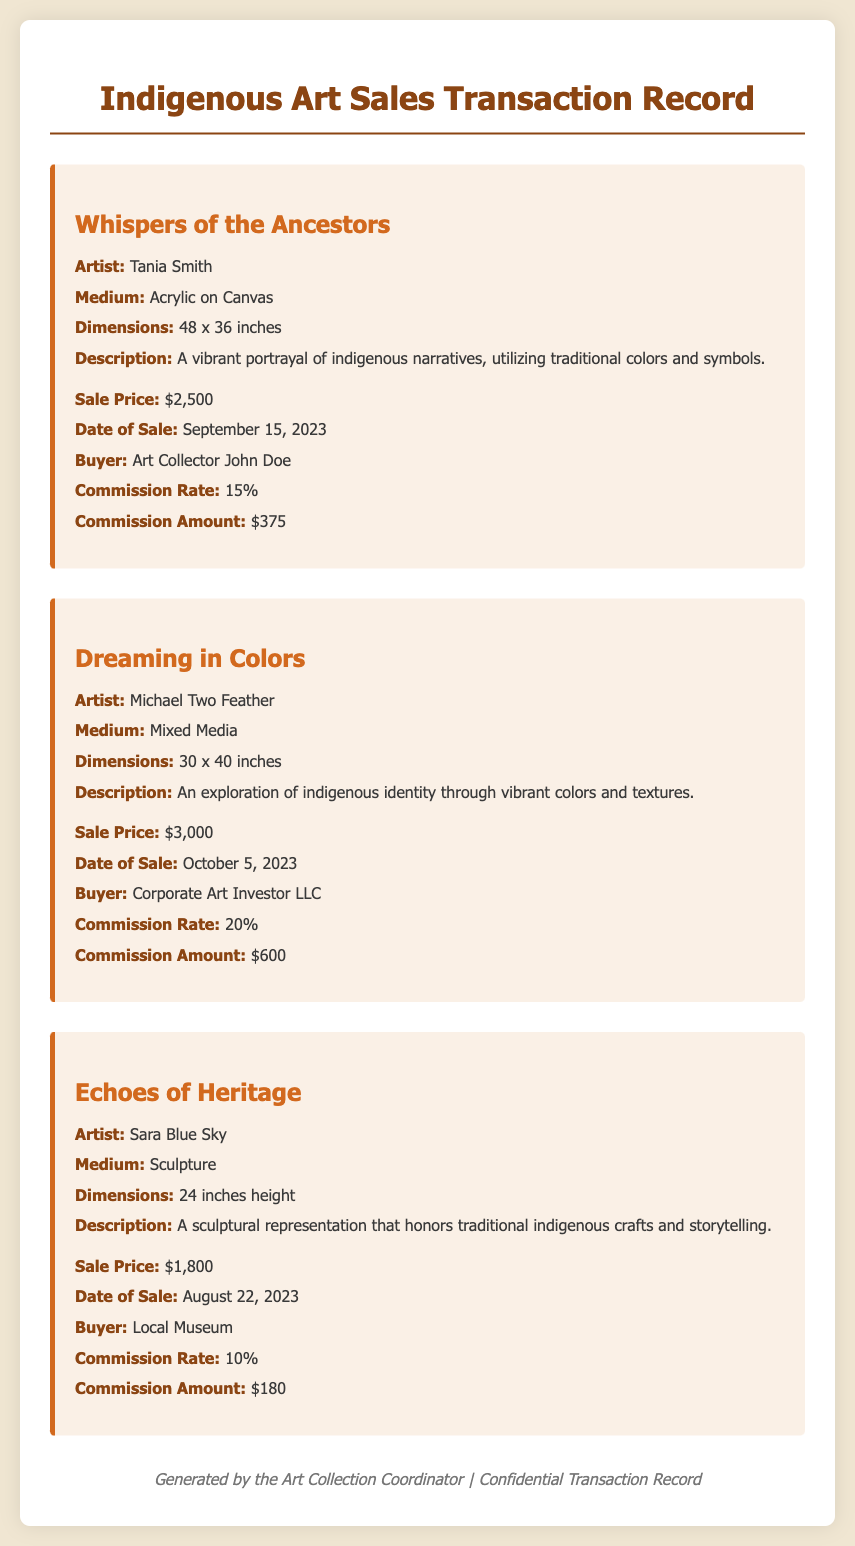What is the artist of "Whispers of the Ancestors"? The artist of "Whispers of the Ancestors" is mentioned in the art piece details.
Answer: Tania Smith What is the sale price of "Dreaming in Colors"? The sale price of "Dreaming in Colors" is listed in the sale details.
Answer: $3,000 What date was "Echoes of Heritage" sold? The date of the sale for "Echoes of Heritage" is provided in the sale details.
Answer: August 22, 2023 What is the commission amount for "Whispers of the Ancestors"? The commission amount is calculated based on the sale price and commission rate.
Answer: $375 Which buyer purchased "Dreaming in Colors"? The buyer's name for "Dreaming in Colors" is specified in the sale details.
Answer: Corporate Art Investor LLC What is the medium of the artwork "Echoes of Heritage"? The medium is described in the details of the art piece.
Answer: Sculpture How much commission was taken from the sale of "Echoes of Heritage"? The commission is expressed as a percentage of the sale price in the details.
Answer: $180 Who generated this document? The footer indicates the person responsible for generating the document.
Answer: Art Collection Coordinator 